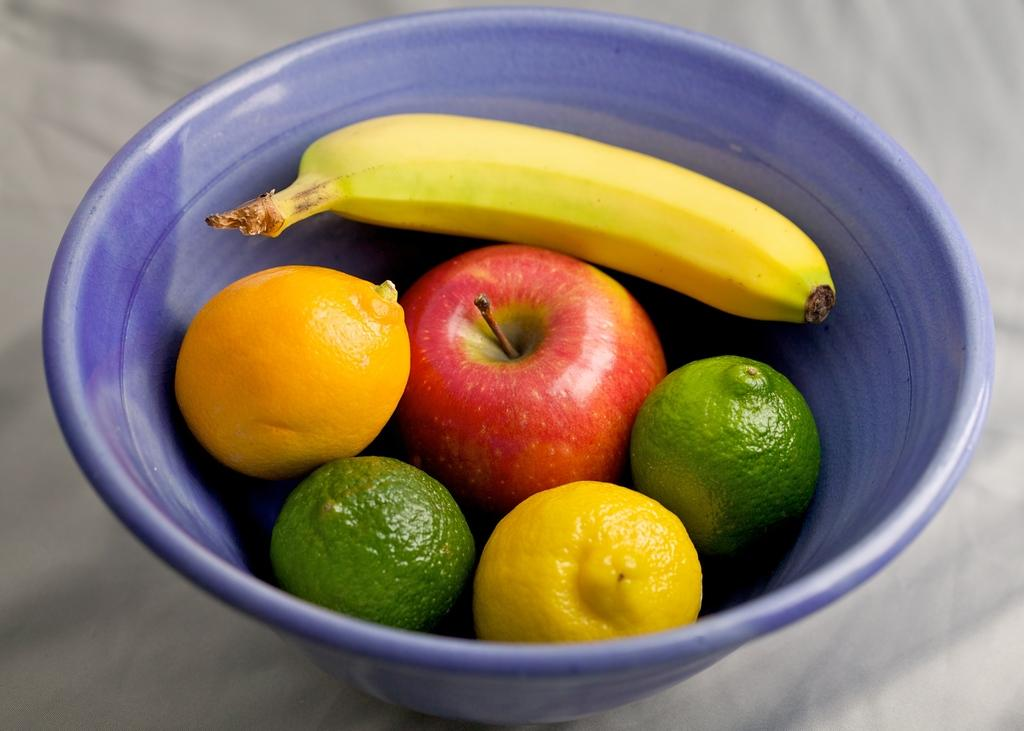What color is the bowl in the image? The bowl in the image is blue. What types of fruits can be seen in the bowl? There are apple, orange, and banana fruits in the bowl. What type of fuel is being used to power the apple in the image? There is no fuel present in the image, as it features a bowl of fruits. What type of mint is being used to garnish the banana in the image? There is no mint present in the image, as it features a bowl of fruits. 